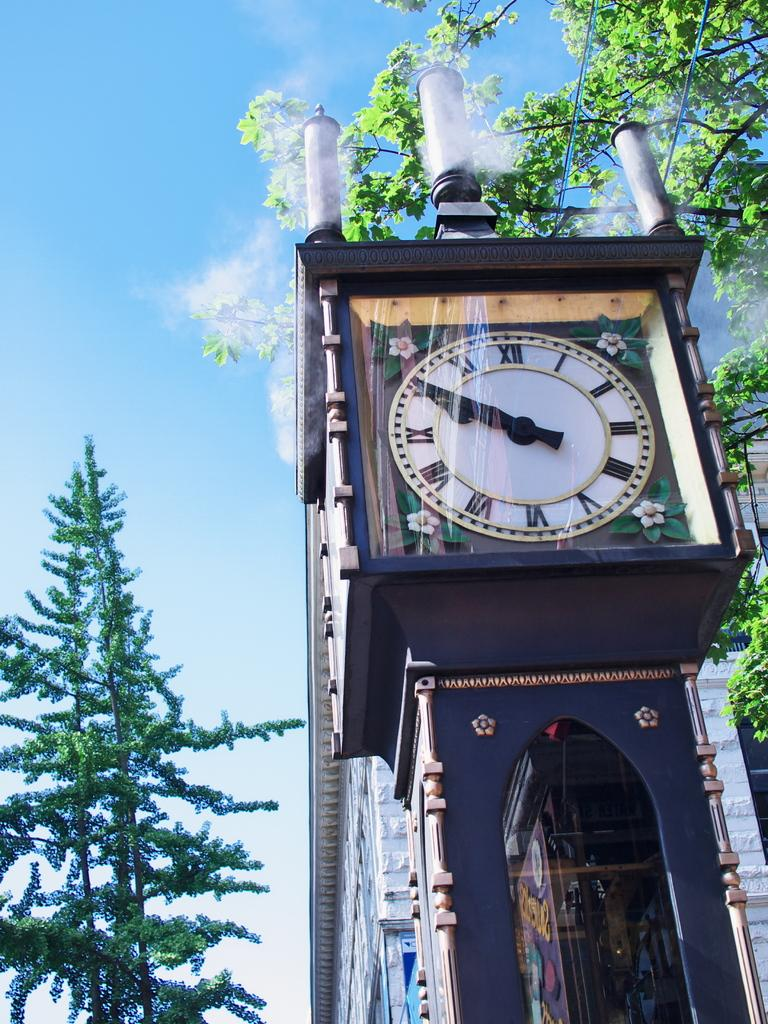Provide a one-sentence caption for the provided image. On a beautiful, sunny day, a large clock tower displays 9:50. 